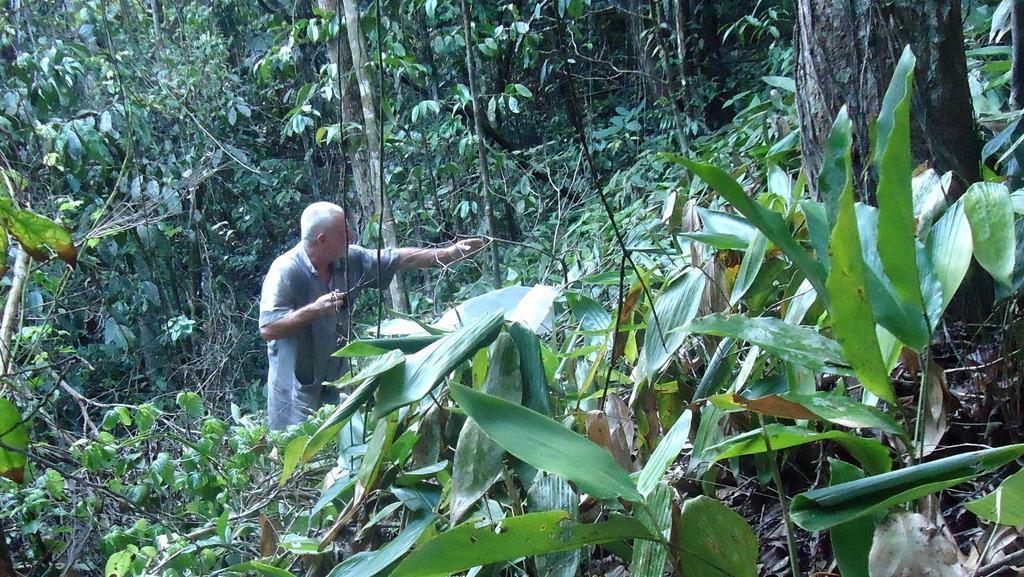How would you summarize this image in a sentence or two? In this image I see a man over here and I see number of trees and plants. 